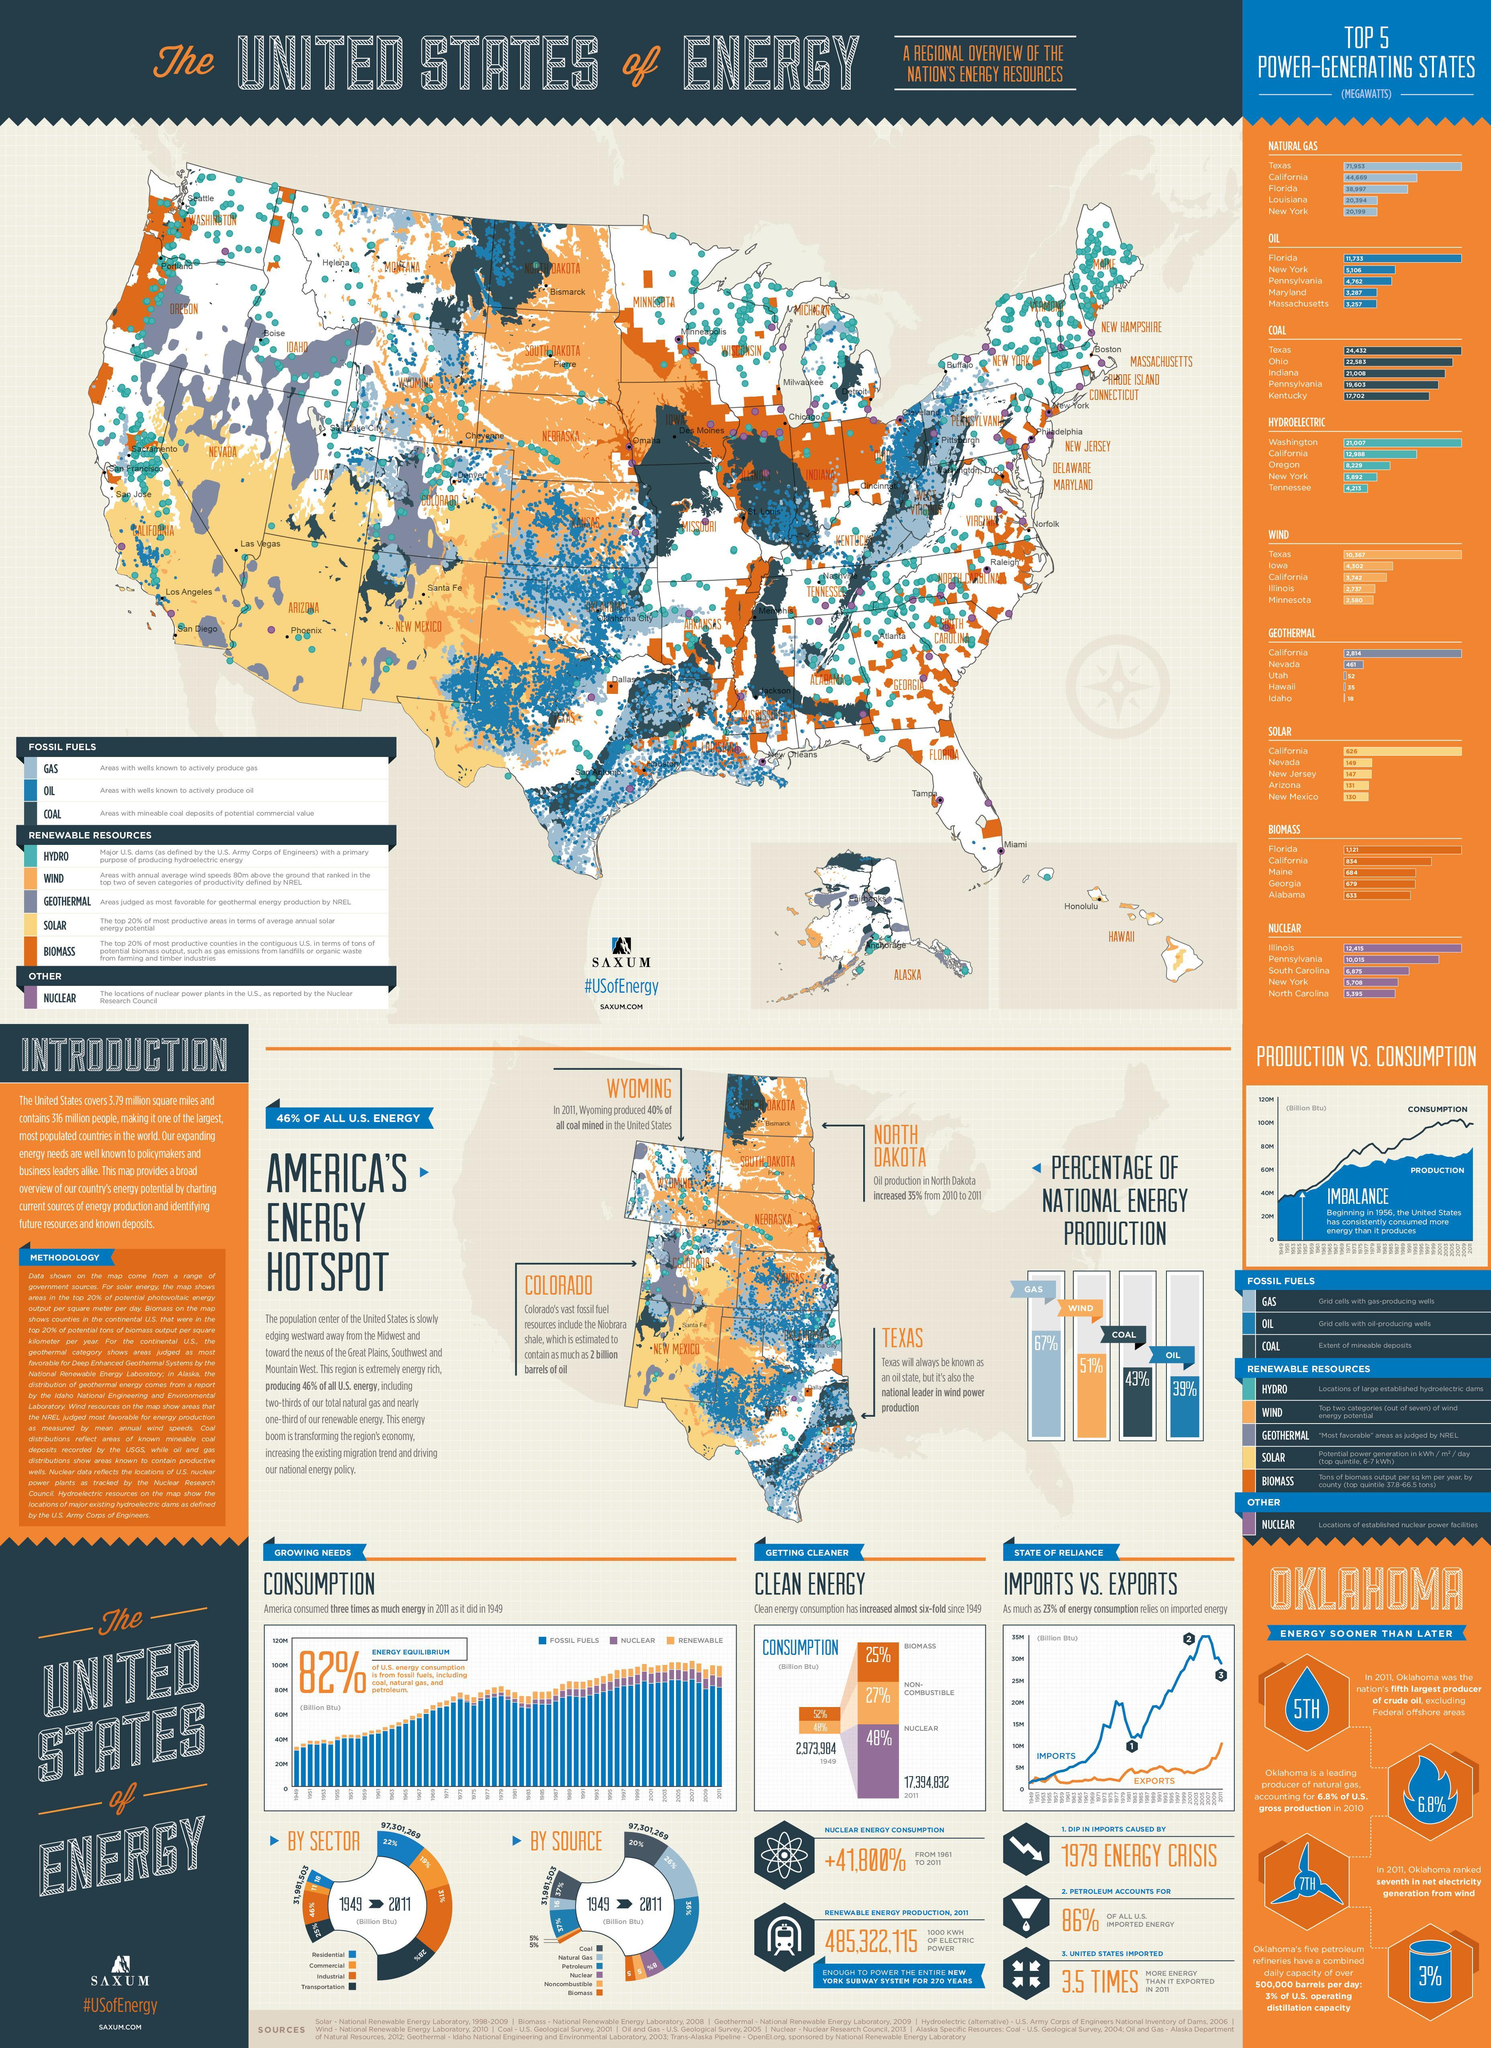which energy source has the least percentage in national energy production?
Answer the question with a short phrase. oil which energy resource is commonly found in Nebraska? wind what is the color of the bar graph that has the second highest percentage in national energy production, blue or orange? orange which energy resource is commonly found in south western part of america? solar which energy source has the third highest percentage in national energy production? coal which energy resource is prominent in South Dakota? wind which energy resource is the most prominent in north east america? hydro which energy source has the second highest percentage in national energy production? wind which energy resource is prominent in Hawaii other than wind? solar 